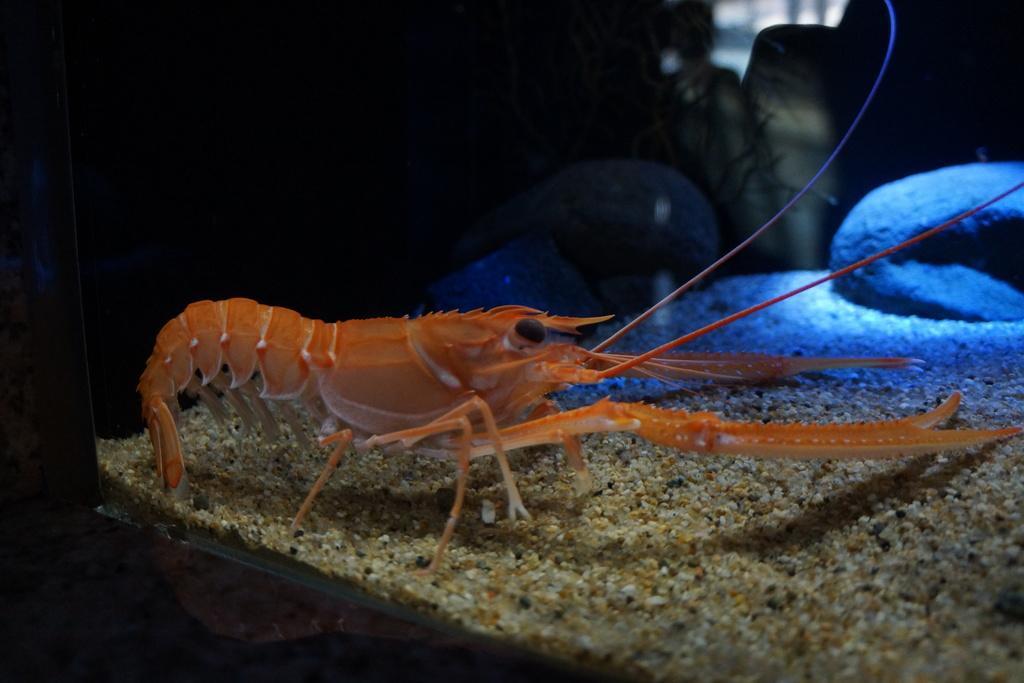How would you summarize this image in a sentence or two? In this image we can see some creature which is called american lobster is in the aquarium and in the background of the image we can see some stones. 